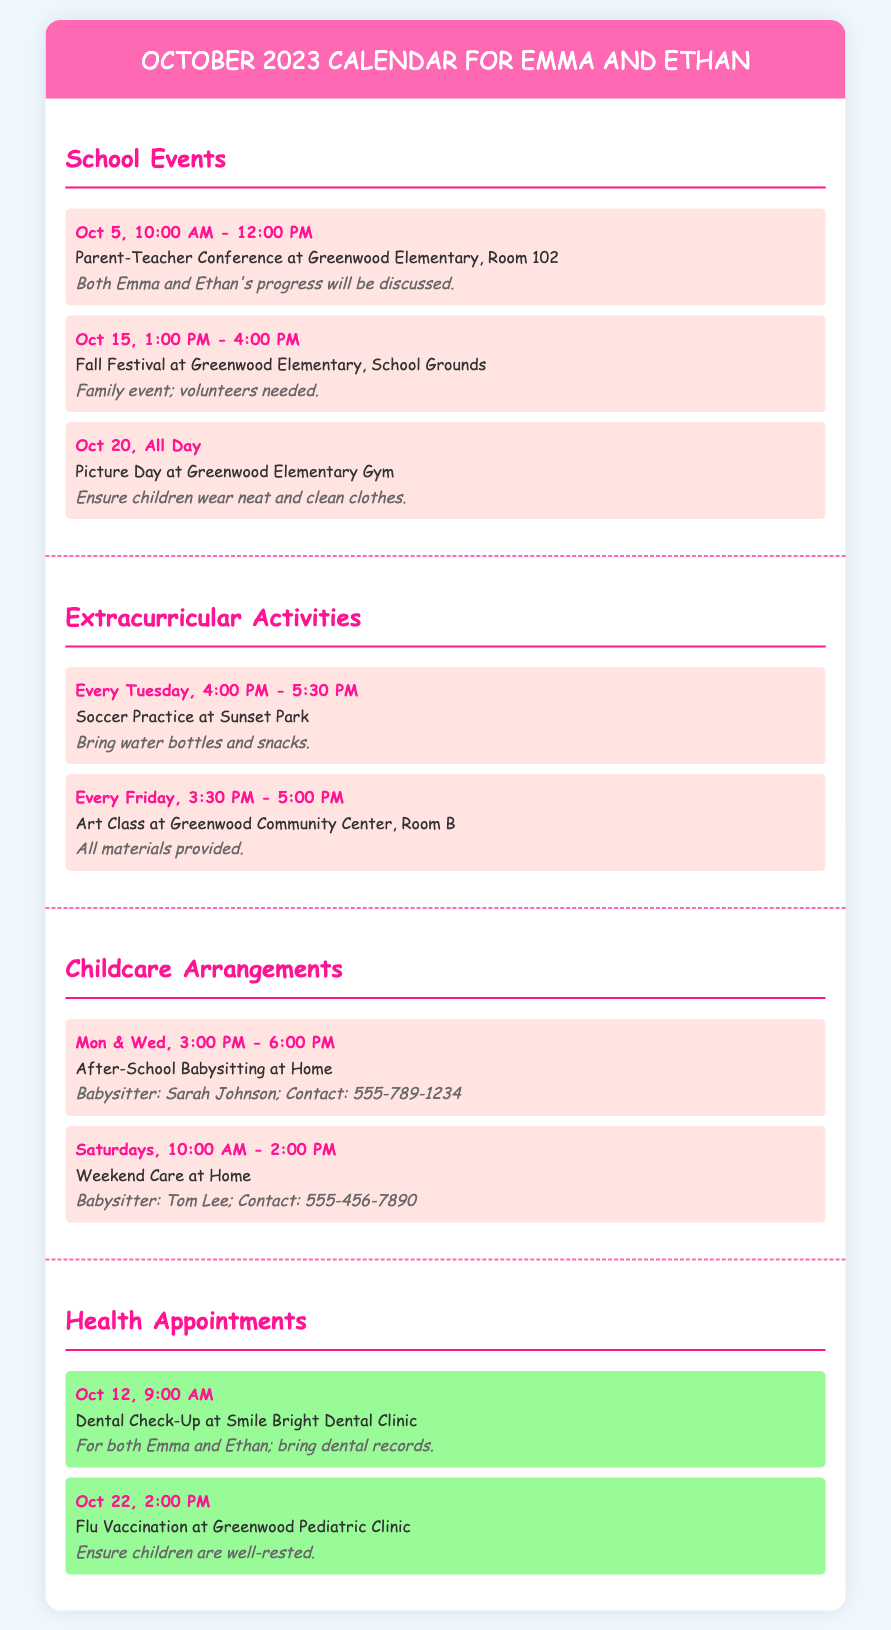What date is the Parent-Teacher Conference? The document states the date and time for the Parent-Teacher Conference as October 5 from 10:00 AM to 12:00 PM.
Answer: Oct 5, 10:00 AM - 12:00 PM What event occurs on October 15? The document lists the Fall Festival at Greenwood Elementary occurring on October 15 from 1:00 PM to 4:00 PM.
Answer: Fall Festival What time does Soccer Practice take place? The schedule indicates that Soccer Practice occurs every Tuesday from 4:00 PM to 5:30 PM.
Answer: 4:00 PM - 5:30 PM Who is responsible for After-School Babysitting on Mondays and Wednesdays? The document identifies Sarah Johnson as the babysitter for After-School Babysitting on those days.
Answer: Sarah Johnson What are the dates of health appointments? There are two health appointments listed: October 12 and October 22.
Answer: Oct 12, Oct 22 How many school events are listed in the document? The document includes three school events: the Parent-Teacher Conference, Fall Festival, and Picture Day.
Answer: 3 What type of activity is scheduled every Friday? The document specifies that Art Class is scheduled every Friday from 3:30 PM to 5:00 PM.
Answer: Art Class What should children wear on Picture Day? The document notes that children should wear neat and clean clothes on Picture Day.
Answer: Neat and clean clothes Who should be contacted for weekend care? The document provides the name Tom Lee and his contact number for weekend care.
Answer: Tom Lee 